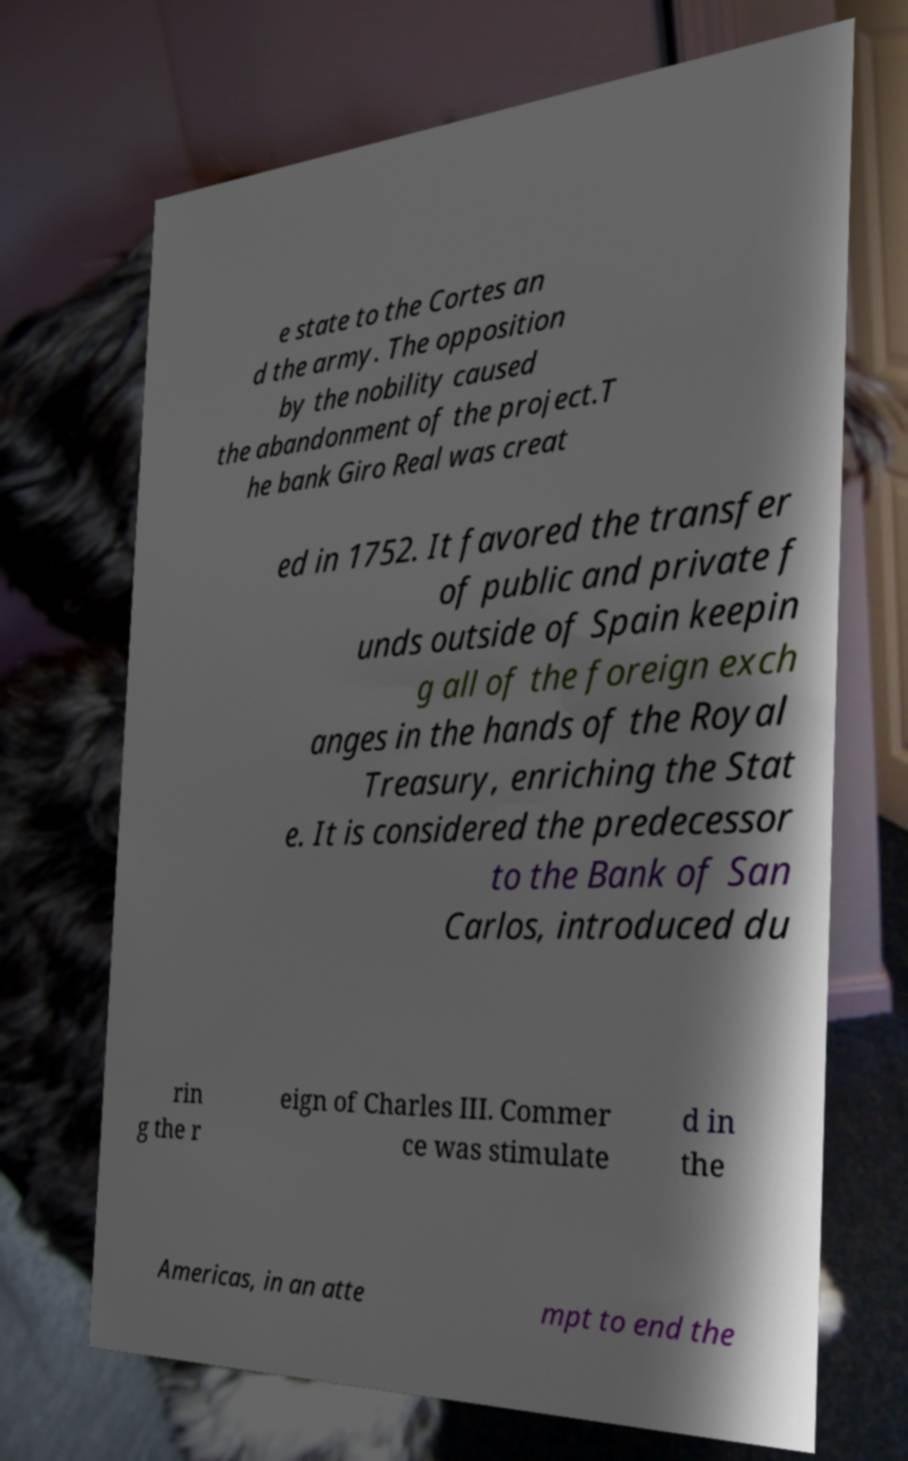Can you read and provide the text displayed in the image?This photo seems to have some interesting text. Can you extract and type it out for me? e state to the Cortes an d the army. The opposition by the nobility caused the abandonment of the project.T he bank Giro Real was creat ed in 1752. It favored the transfer of public and private f unds outside of Spain keepin g all of the foreign exch anges in the hands of the Royal Treasury, enriching the Stat e. It is considered the predecessor to the Bank of San Carlos, introduced du rin g the r eign of Charles III. Commer ce was stimulate d in the Americas, in an atte mpt to end the 